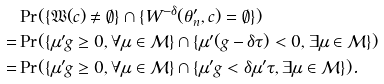Convert formula to latex. <formula><loc_0><loc_0><loc_500><loc_500>& \Pr ( \{ \mathfrak W ( c ) \ne \emptyset \} \cap \{ W ^ { - \delta } ( \theta _ { n } ^ { \prime } , c ) = \emptyset \} ) \\ = & \Pr ( \{ \mu ^ { \prime } g \geq 0 , \forall \mu \in \mathcal { M } \} \cap \{ \mu ^ { \prime } ( g - \delta \tau ) < 0 , \exists \mu \in \mathcal { M } \} ) \\ = & \Pr ( \{ \mu ^ { \prime } g \geq 0 , \forall \mu \in \mathcal { M } \} \cap \{ \mu ^ { \prime } g < \delta \mu ^ { \prime } \tau , \exists \mu \in \mathcal { M } \} ) .</formula> 